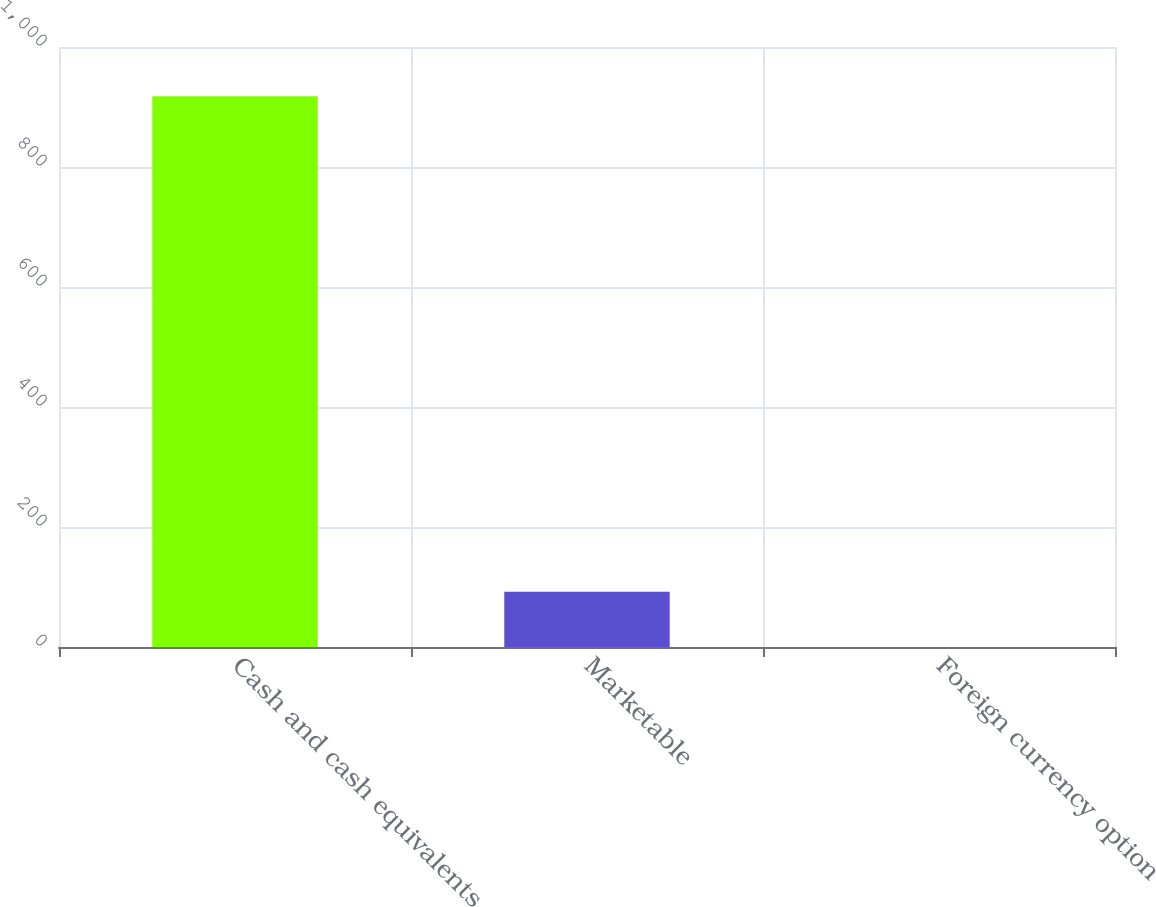Convert chart to OTSL. <chart><loc_0><loc_0><loc_500><loc_500><bar_chart><fcel>Cash and cash equivalents<fcel>Marketable<fcel>Foreign currency option<nl><fcel>917.9<fcel>91.97<fcel>0.2<nl></chart> 